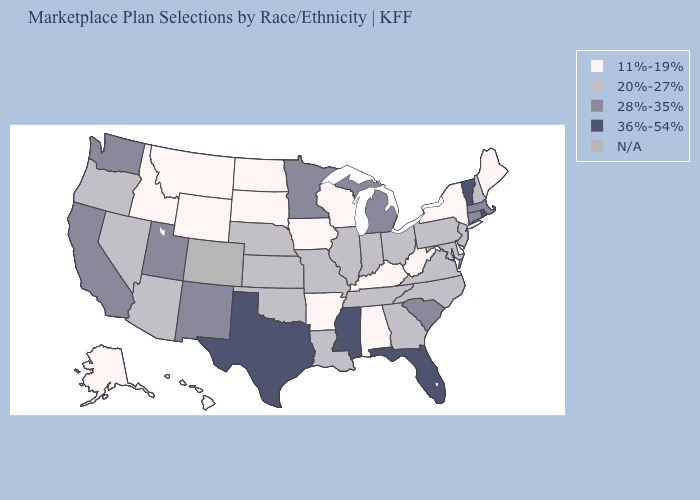What is the lowest value in the USA?
Give a very brief answer. 11%-19%. Name the states that have a value in the range 20%-27%?
Concise answer only. Arizona, Georgia, Illinois, Indiana, Kansas, Louisiana, Maryland, Missouri, Nebraska, Nevada, New Hampshire, New Jersey, North Carolina, Ohio, Oklahoma, Oregon, Pennsylvania, Tennessee, Virginia. Name the states that have a value in the range 36%-54%?
Give a very brief answer. Florida, Mississippi, Rhode Island, Texas, Vermont. Which states have the lowest value in the USA?
Keep it brief. Alabama, Alaska, Arkansas, Delaware, Hawaii, Idaho, Iowa, Kentucky, Maine, Montana, New York, North Dakota, South Dakota, West Virginia, Wisconsin, Wyoming. What is the value of Maine?
Concise answer only. 11%-19%. What is the lowest value in the South?
Concise answer only. 11%-19%. What is the value of Kentucky?
Concise answer only. 11%-19%. Which states have the lowest value in the USA?
Give a very brief answer. Alabama, Alaska, Arkansas, Delaware, Hawaii, Idaho, Iowa, Kentucky, Maine, Montana, New York, North Dakota, South Dakota, West Virginia, Wisconsin, Wyoming. What is the lowest value in the USA?
Answer briefly. 11%-19%. What is the value of Utah?
Keep it brief. 28%-35%. Name the states that have a value in the range 11%-19%?
Write a very short answer. Alabama, Alaska, Arkansas, Delaware, Hawaii, Idaho, Iowa, Kentucky, Maine, Montana, New York, North Dakota, South Dakota, West Virginia, Wisconsin, Wyoming. What is the highest value in states that border Nebraska?
Write a very short answer. 20%-27%. What is the value of New Mexico?
Be succinct. 28%-35%. What is the value of Hawaii?
Quick response, please. 11%-19%. 